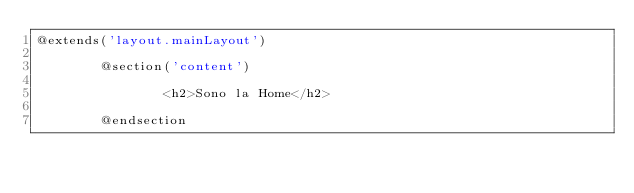Convert code to text. <code><loc_0><loc_0><loc_500><loc_500><_PHP_>@extends('layout.mainLayout')

        @section('content')
            
                <h2>Sono la Home</h2>
            
        @endsection


        
 </code> 